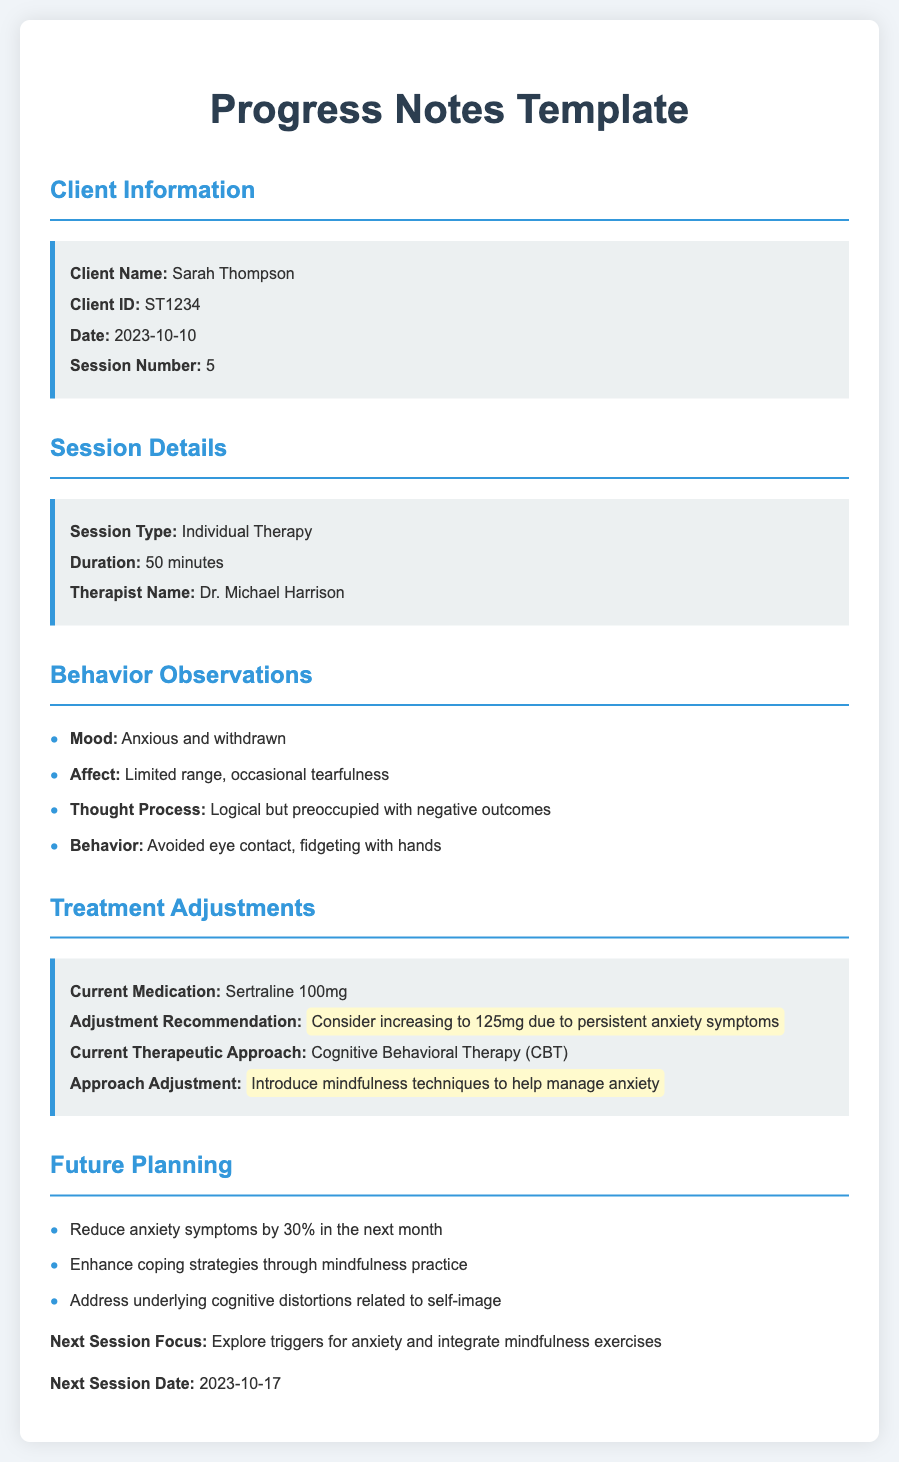What is the client's name? The client's name is clearly stated in the document's client information section.
Answer: Sarah Thompson What is the session date? The date of the session is noted in the client information section.
Answer: 2023-10-10 How long was the session? The duration of the session is mentioned in the session details.
Answer: 50 minutes What is the current medication prescribed? The document specifies the current medication under treatment adjustments.
Answer: Sertraline 100mg What is the adjustment recommendation for medication? The treatment adjustments section outlines specific recommendations.
Answer: Consider increasing to 125mg due to persistent anxiety symptoms What therapeutic approach is currently being used? The current therapeutic approach is detailed in the treatment adjustments section.
Answer: Cognitive Behavioral Therapy (CBT) What mood was observed during the session? The mood is listed in the behavior observations part of the document.
Answer: Anxious and withdrawn What is the main focus for the next session? The specific focus of the next session is highlighted in the future planning section.
Answer: Explore triggers for anxiety and integrate mindfulness exercises When is the next session scheduled? The date for the next session is noted at the end of the document.
Answer: 2023-10-17 